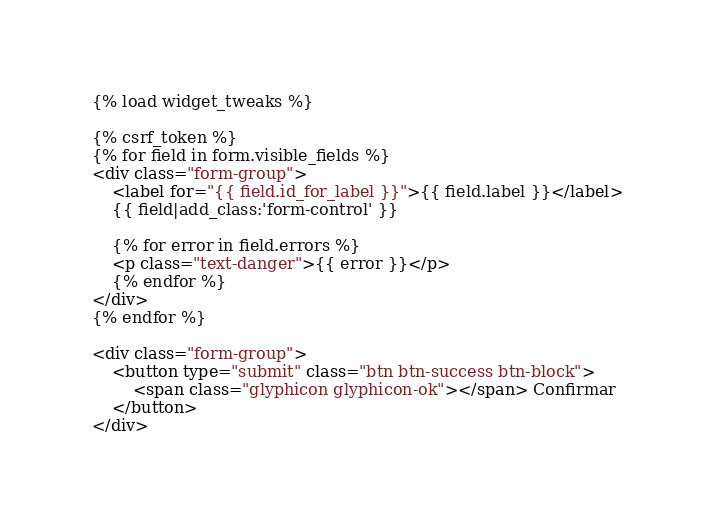<code> <loc_0><loc_0><loc_500><loc_500><_HTML_>{% load widget_tweaks %}

{% csrf_token %}
{% for field in form.visible_fields %}
<div class="form-group">
    <label for="{{ field.id_for_label }}">{{ field.label }}</label>
    {{ field|add_class:'form-control' }}

    {% for error in field.errors %}
    <p class="text-danger">{{ error }}</p>
    {% endfor %}
</div>
{% endfor %}

<div class="form-group">
    <button type="submit" class="btn btn-success btn-block">
        <span class="glyphicon glyphicon-ok"></span> Confirmar
    </button>
</div></code> 